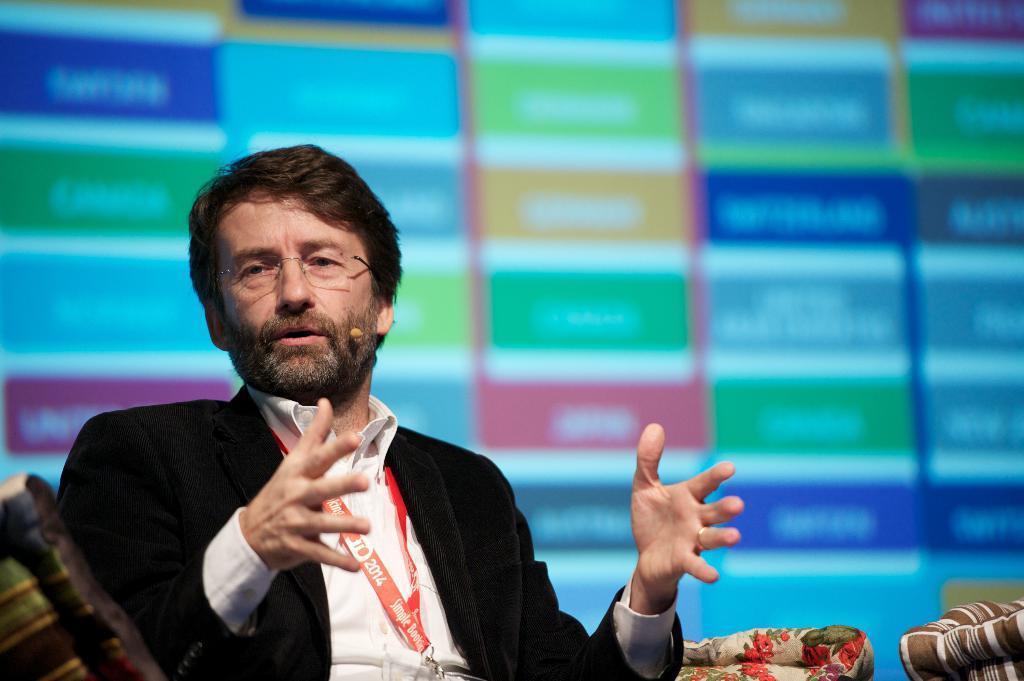Could you give a brief overview of what you see in this image? In this picture there is a man sitting in the chair. He is wearing black color coat and a red color tag in his neck. In the background it is blurred. 